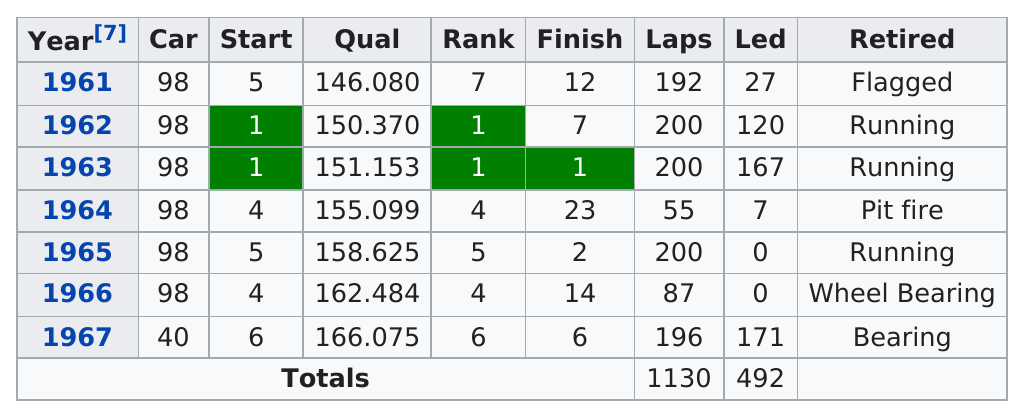Give some essential details in this illustration. Sir Mo Farah did not lead the race the most number of years in the 2017 London Marathon. The three years in which he led the race the least are 1965, 1966, and 1967. Jones has been flagged in at least one Indianapolis 500 race. The #1 car from 1962-1963 was ranked as such. As of the 2023 Indianapolis 500, a total of 1,130 laps have been driven. I will finish the races a total of 3 times while running. 